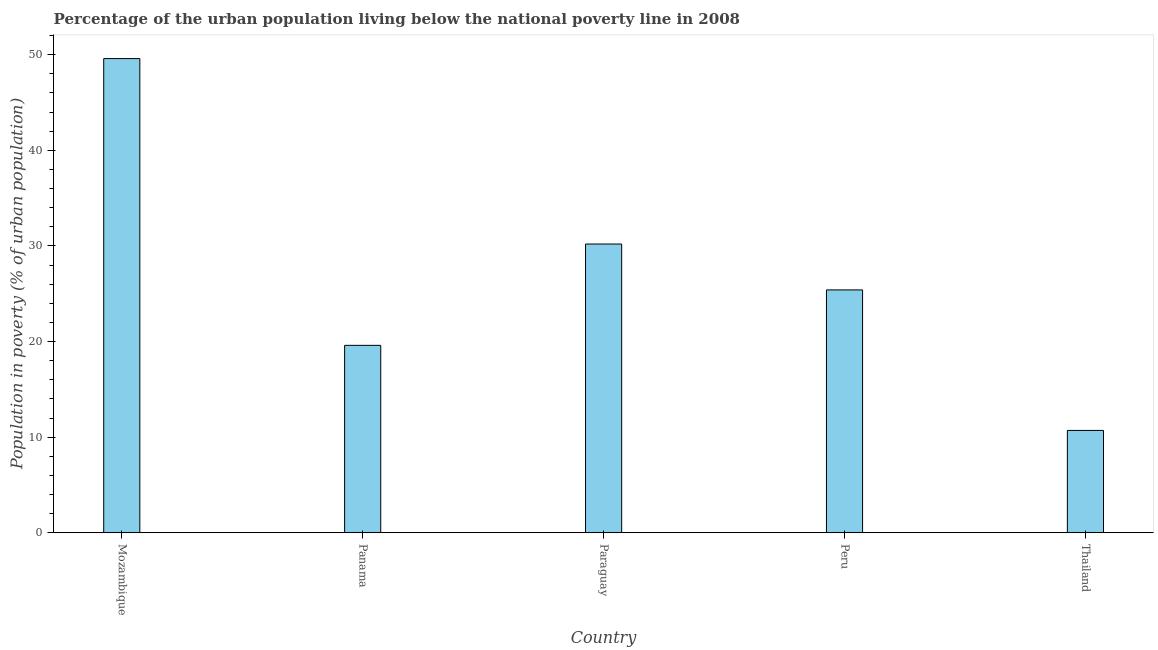Does the graph contain any zero values?
Your response must be concise. No. What is the title of the graph?
Give a very brief answer. Percentage of the urban population living below the national poverty line in 2008. What is the label or title of the X-axis?
Make the answer very short. Country. What is the label or title of the Y-axis?
Make the answer very short. Population in poverty (% of urban population). What is the percentage of urban population living below poverty line in Peru?
Your answer should be very brief. 25.4. Across all countries, what is the maximum percentage of urban population living below poverty line?
Offer a very short reply. 49.6. In which country was the percentage of urban population living below poverty line maximum?
Ensure brevity in your answer.  Mozambique. In which country was the percentage of urban population living below poverty line minimum?
Provide a succinct answer. Thailand. What is the sum of the percentage of urban population living below poverty line?
Your answer should be compact. 135.5. What is the average percentage of urban population living below poverty line per country?
Make the answer very short. 27.1. What is the median percentage of urban population living below poverty line?
Keep it short and to the point. 25.4. What is the ratio of the percentage of urban population living below poverty line in Mozambique to that in Paraguay?
Provide a succinct answer. 1.64. Is the percentage of urban population living below poverty line in Mozambique less than that in Thailand?
Offer a very short reply. No. What is the difference between the highest and the lowest percentage of urban population living below poverty line?
Offer a very short reply. 38.9. Are all the bars in the graph horizontal?
Provide a short and direct response. No. What is the difference between two consecutive major ticks on the Y-axis?
Give a very brief answer. 10. What is the Population in poverty (% of urban population) in Mozambique?
Your response must be concise. 49.6. What is the Population in poverty (% of urban population) in Panama?
Your response must be concise. 19.6. What is the Population in poverty (% of urban population) of Paraguay?
Keep it short and to the point. 30.2. What is the Population in poverty (% of urban population) of Peru?
Make the answer very short. 25.4. What is the Population in poverty (% of urban population) of Thailand?
Your answer should be compact. 10.7. What is the difference between the Population in poverty (% of urban population) in Mozambique and Panama?
Your response must be concise. 30. What is the difference between the Population in poverty (% of urban population) in Mozambique and Paraguay?
Your answer should be compact. 19.4. What is the difference between the Population in poverty (% of urban population) in Mozambique and Peru?
Your answer should be very brief. 24.2. What is the difference between the Population in poverty (% of urban population) in Mozambique and Thailand?
Ensure brevity in your answer.  38.9. What is the difference between the Population in poverty (% of urban population) in Panama and Paraguay?
Offer a terse response. -10.6. What is the ratio of the Population in poverty (% of urban population) in Mozambique to that in Panama?
Provide a short and direct response. 2.53. What is the ratio of the Population in poverty (% of urban population) in Mozambique to that in Paraguay?
Your answer should be compact. 1.64. What is the ratio of the Population in poverty (% of urban population) in Mozambique to that in Peru?
Offer a terse response. 1.95. What is the ratio of the Population in poverty (% of urban population) in Mozambique to that in Thailand?
Provide a succinct answer. 4.64. What is the ratio of the Population in poverty (% of urban population) in Panama to that in Paraguay?
Your response must be concise. 0.65. What is the ratio of the Population in poverty (% of urban population) in Panama to that in Peru?
Ensure brevity in your answer.  0.77. What is the ratio of the Population in poverty (% of urban population) in Panama to that in Thailand?
Provide a succinct answer. 1.83. What is the ratio of the Population in poverty (% of urban population) in Paraguay to that in Peru?
Your answer should be compact. 1.19. What is the ratio of the Population in poverty (% of urban population) in Paraguay to that in Thailand?
Keep it short and to the point. 2.82. What is the ratio of the Population in poverty (% of urban population) in Peru to that in Thailand?
Provide a short and direct response. 2.37. 